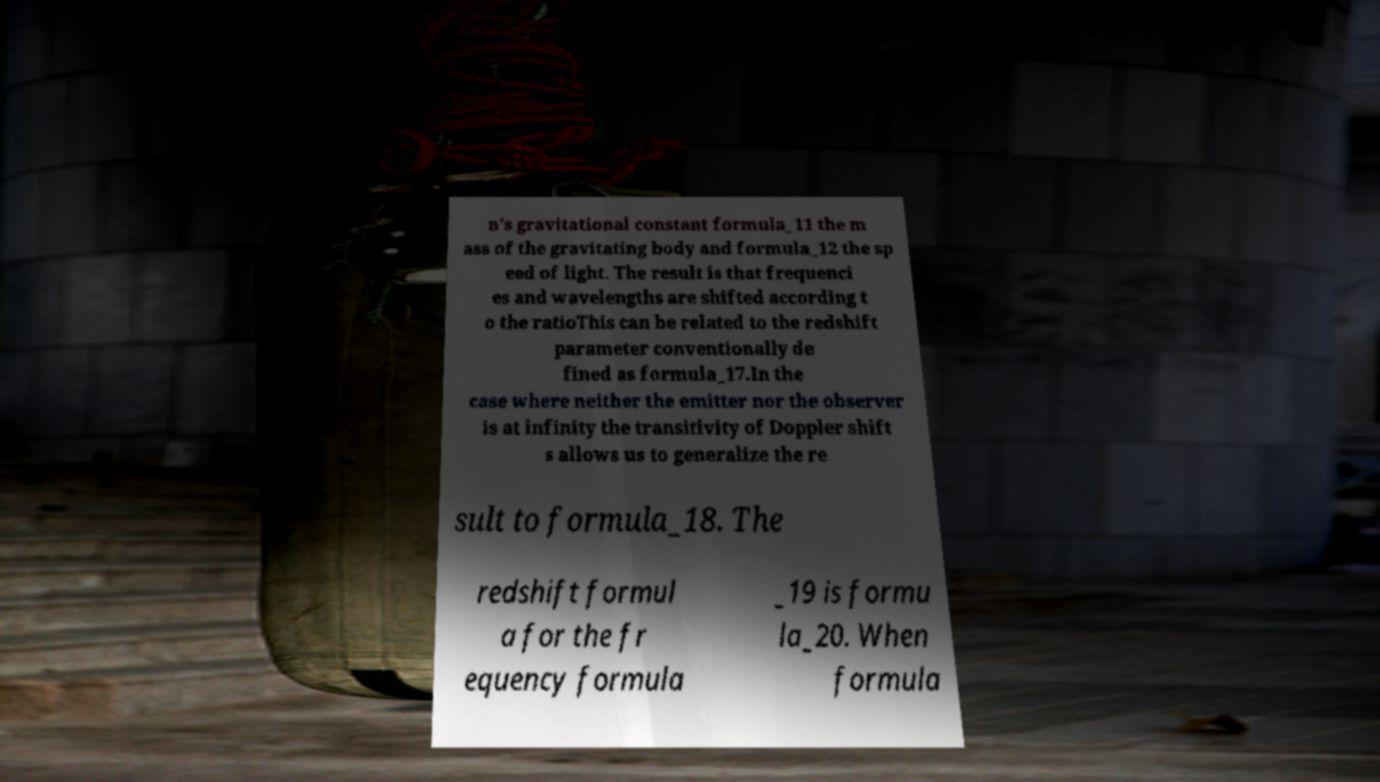Please identify and transcribe the text found in this image. n's gravitational constant formula_11 the m ass of the gravitating body and formula_12 the sp eed of light. The result is that frequenci es and wavelengths are shifted according t o the ratioThis can be related to the redshift parameter conventionally de fined as formula_17.In the case where neither the emitter nor the observer is at infinity the transitivity of Doppler shift s allows us to generalize the re sult to formula_18. The redshift formul a for the fr equency formula _19 is formu la_20. When formula 